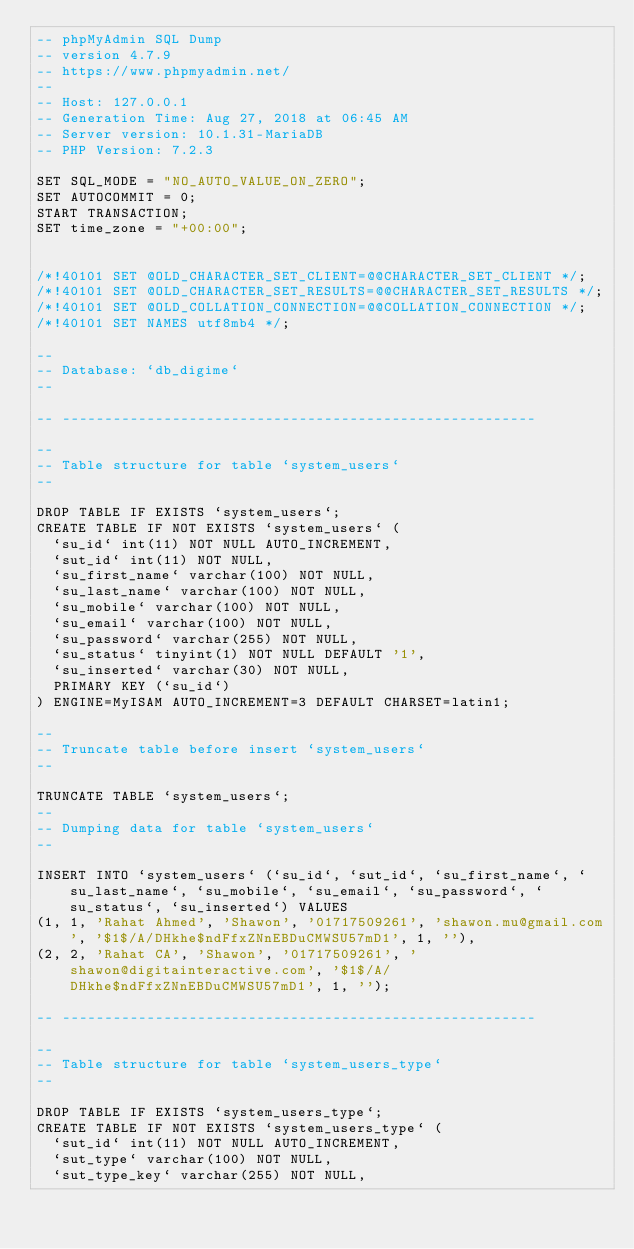<code> <loc_0><loc_0><loc_500><loc_500><_SQL_>-- phpMyAdmin SQL Dump
-- version 4.7.9
-- https://www.phpmyadmin.net/
--
-- Host: 127.0.0.1
-- Generation Time: Aug 27, 2018 at 06:45 AM
-- Server version: 10.1.31-MariaDB
-- PHP Version: 7.2.3

SET SQL_MODE = "NO_AUTO_VALUE_ON_ZERO";
SET AUTOCOMMIT = 0;
START TRANSACTION;
SET time_zone = "+00:00";


/*!40101 SET @OLD_CHARACTER_SET_CLIENT=@@CHARACTER_SET_CLIENT */;
/*!40101 SET @OLD_CHARACTER_SET_RESULTS=@@CHARACTER_SET_RESULTS */;
/*!40101 SET @OLD_COLLATION_CONNECTION=@@COLLATION_CONNECTION */;
/*!40101 SET NAMES utf8mb4 */;

--
-- Database: `db_digime`
--

-- --------------------------------------------------------

--
-- Table structure for table `system_users`
--

DROP TABLE IF EXISTS `system_users`;
CREATE TABLE IF NOT EXISTS `system_users` (
  `su_id` int(11) NOT NULL AUTO_INCREMENT,
  `sut_id` int(11) NOT NULL,
  `su_first_name` varchar(100) NOT NULL,
  `su_last_name` varchar(100) NOT NULL,
  `su_mobile` varchar(100) NOT NULL,
  `su_email` varchar(100) NOT NULL,
  `su_password` varchar(255) NOT NULL,
  `su_status` tinyint(1) NOT NULL DEFAULT '1',
  `su_inserted` varchar(30) NOT NULL,
  PRIMARY KEY (`su_id`)
) ENGINE=MyISAM AUTO_INCREMENT=3 DEFAULT CHARSET=latin1;

--
-- Truncate table before insert `system_users`
--

TRUNCATE TABLE `system_users`;
--
-- Dumping data for table `system_users`
--

INSERT INTO `system_users` (`su_id`, `sut_id`, `su_first_name`, `su_last_name`, `su_mobile`, `su_email`, `su_password`, `su_status`, `su_inserted`) VALUES
(1, 1, 'Rahat Ahmed', 'Shawon', '01717509261', 'shawon.mu@gmail.com', '$1$/A/DHkhe$ndFfxZNnEBDuCMWSU57mD1', 1, ''),
(2, 2, 'Rahat CA', 'Shawon', '01717509261', 'shawon@digitainteractive.com', '$1$/A/DHkhe$ndFfxZNnEBDuCMWSU57mD1', 1, '');

-- --------------------------------------------------------

--
-- Table structure for table `system_users_type`
--

DROP TABLE IF EXISTS `system_users_type`;
CREATE TABLE IF NOT EXISTS `system_users_type` (
  `sut_id` int(11) NOT NULL AUTO_INCREMENT,
  `sut_type` varchar(100) NOT NULL,
  `sut_type_key` varchar(255) NOT NULL,</code> 